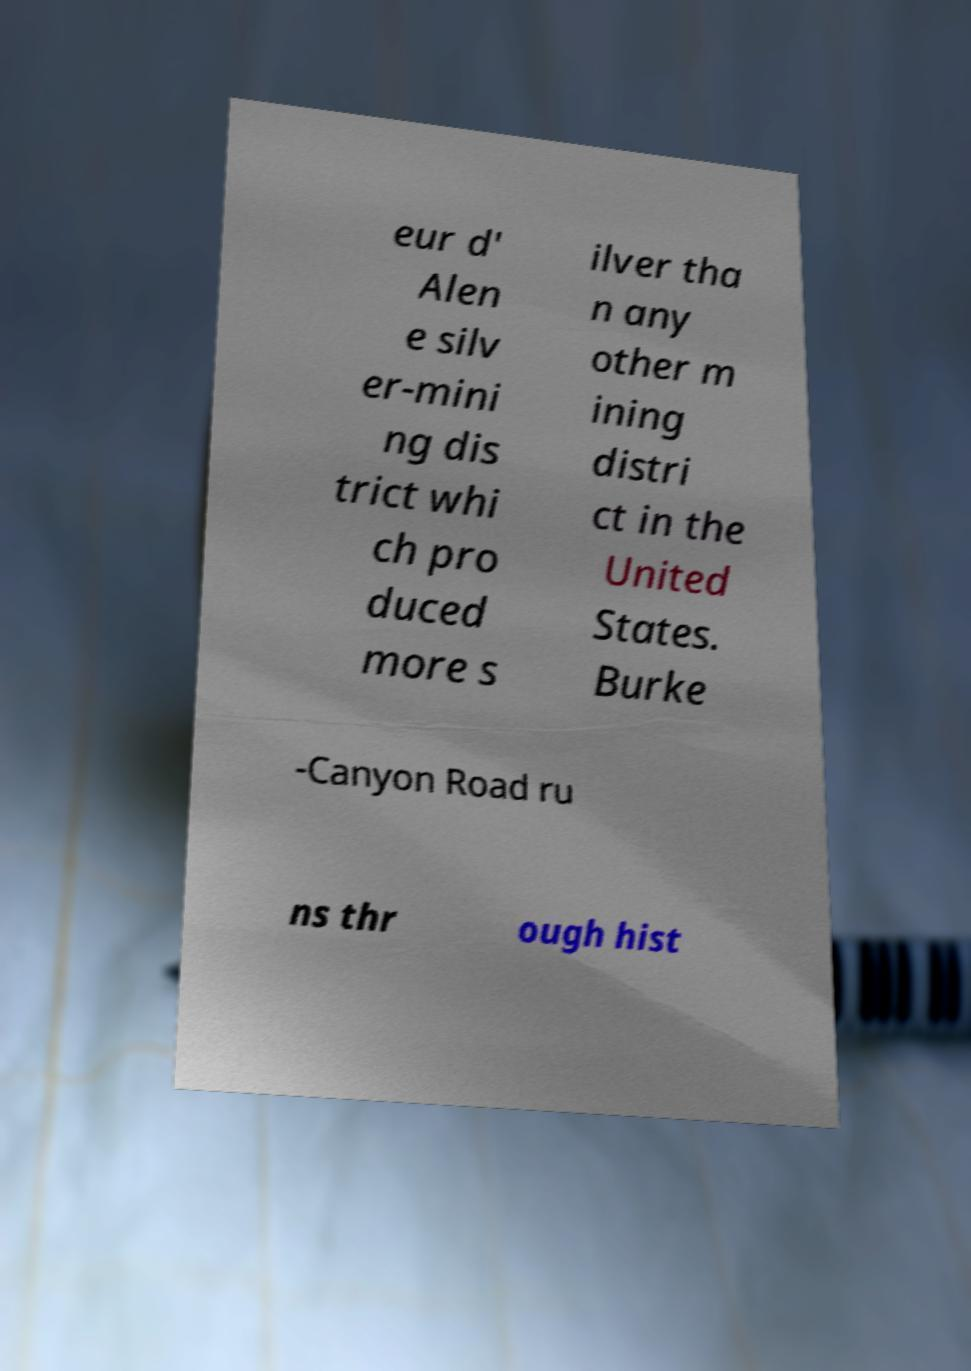Can you accurately transcribe the text from the provided image for me? eur d' Alen e silv er-mini ng dis trict whi ch pro duced more s ilver tha n any other m ining distri ct in the United States. Burke -Canyon Road ru ns thr ough hist 